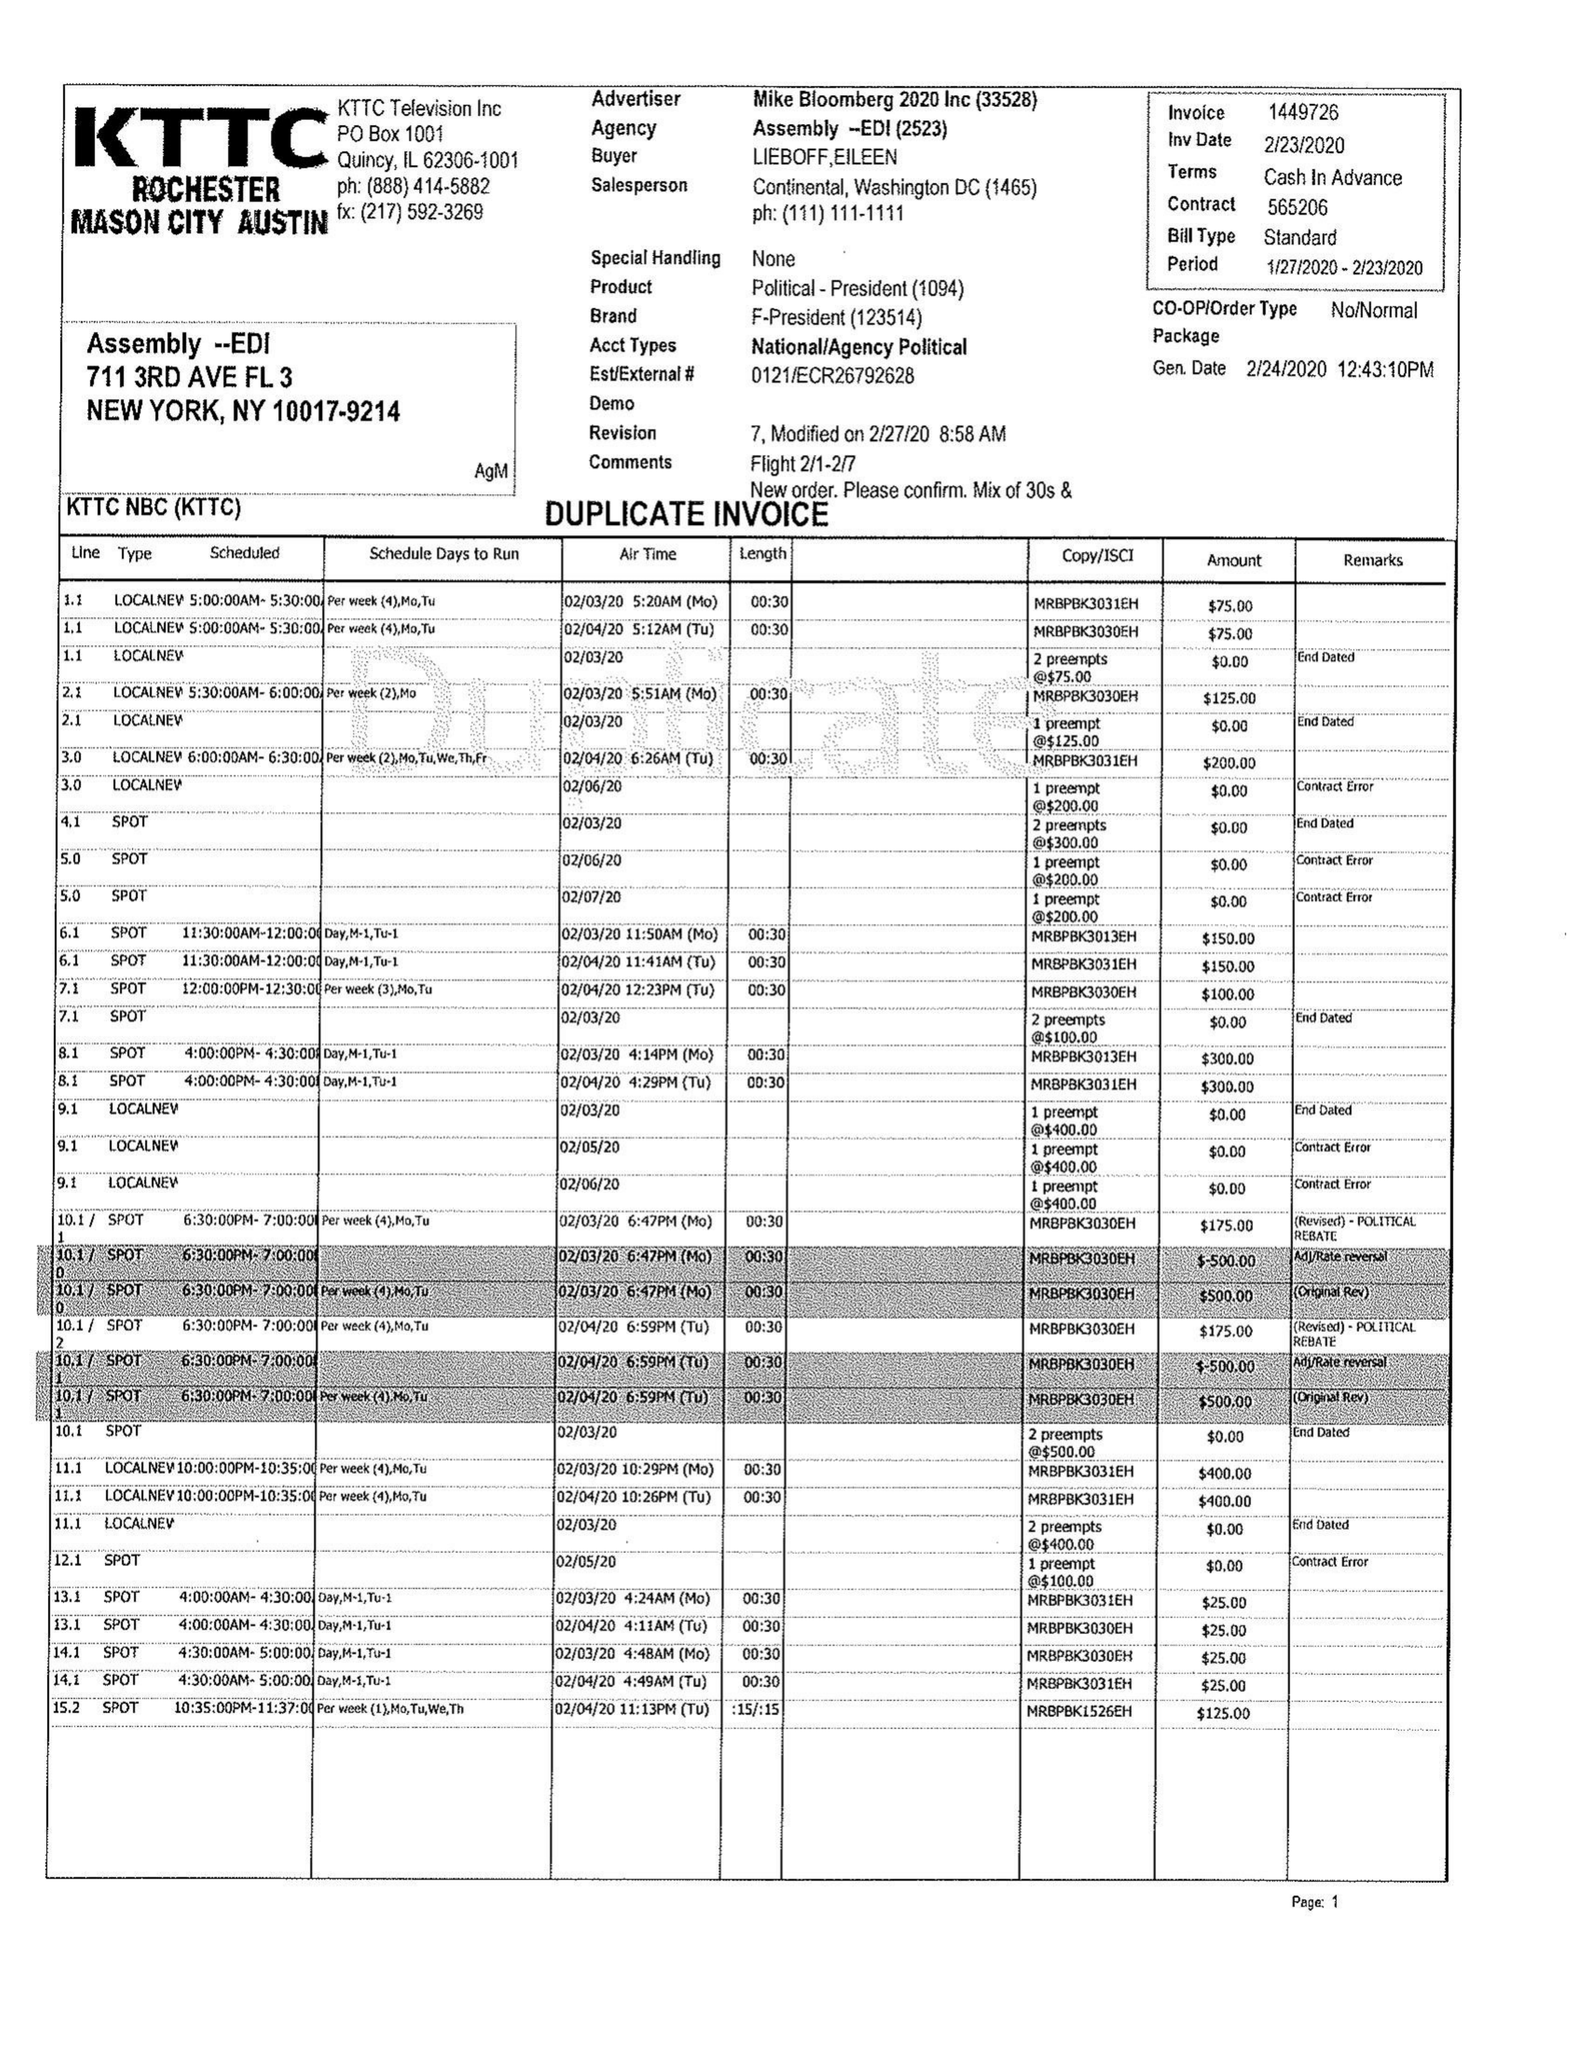What is the value for the flight_from?
Answer the question using a single word or phrase. 01/27/20 